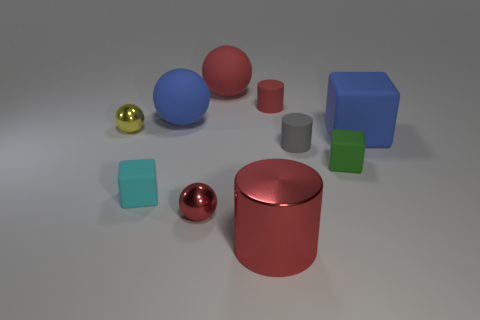How many other things are the same color as the metal cylinder?
Give a very brief answer. 3. There is a tiny green rubber thing; does it have the same shape as the big blue matte object that is on the right side of the green thing?
Make the answer very short. Yes. Is the number of green rubber blocks behind the tiny yellow sphere less than the number of yellow spheres that are on the left side of the big block?
Offer a terse response. Yes. There is another small object that is the same shape as the yellow metallic thing; what is it made of?
Keep it short and to the point. Metal. What shape is the small gray thing that is made of the same material as the green block?
Your answer should be compact. Cylinder. What number of other things are the same shape as the yellow metal thing?
Keep it short and to the point. 3. What is the shape of the big red thing in front of the small cyan cube in front of the yellow object?
Provide a short and direct response. Cylinder. There is a red metal sphere to the right of the cyan object; does it have the same size as the red rubber cylinder?
Offer a very short reply. Yes. What is the size of the rubber thing that is both in front of the blue matte ball and behind the tiny gray matte thing?
Make the answer very short. Large. What number of things have the same size as the shiny cylinder?
Your answer should be very brief. 3. 